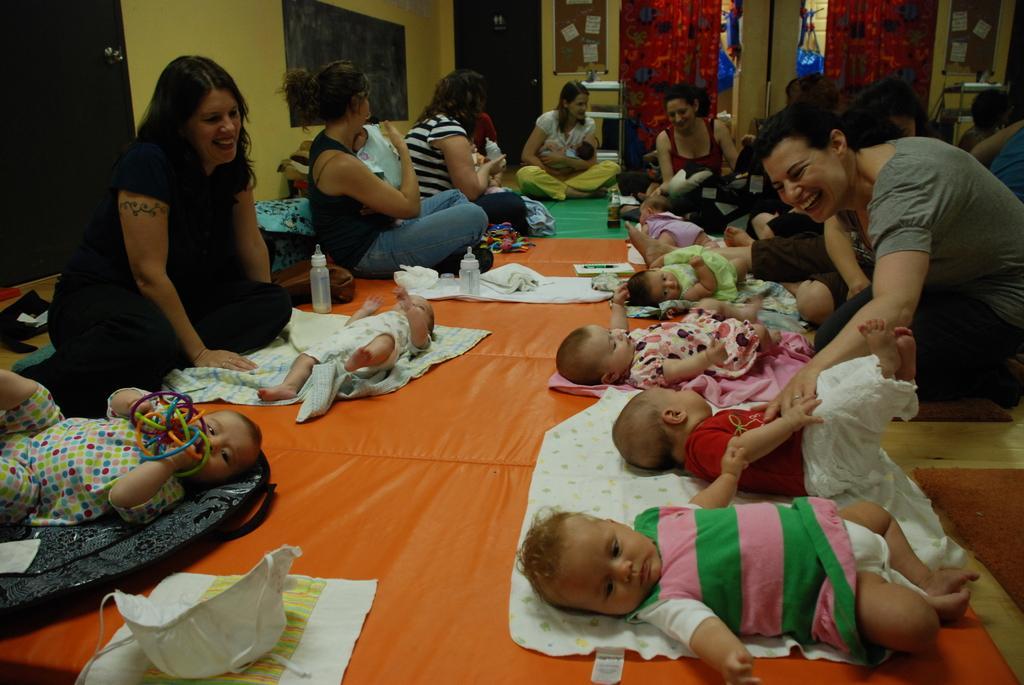Could you give a brief overview of what you see in this image? In this picture we can see a group of women sitting on the floor and a group of children's lying, bottles, clothes and in the background we can see curtains, wall. 